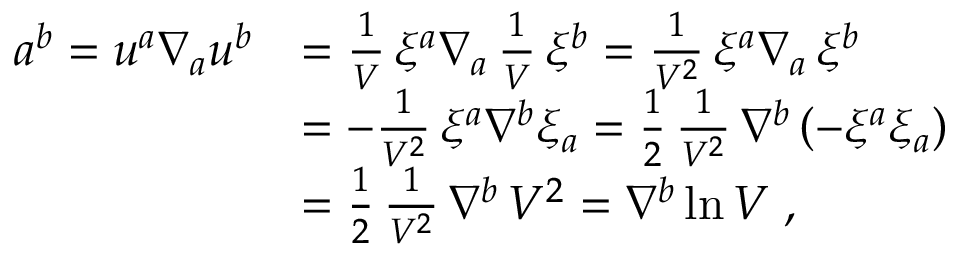Convert formula to latex. <formula><loc_0><loc_0><loc_500><loc_500>\begin{array} { l l } { { a ^ { b } = u ^ { a } \nabla _ { a } u ^ { b } } } & { { = { \frac { 1 } { V } } \, \xi ^ { a } \nabla _ { a } \, { \frac { 1 } { V } } \, \xi ^ { b } = { \frac { 1 } { V ^ { 2 } } } \, \xi ^ { a } \nabla _ { a } \, \xi ^ { b } } } & { { = - { \frac { 1 } { V ^ { 2 } } } \, \xi ^ { a } \nabla ^ { b } \xi _ { a } = { \frac { 1 } { 2 } } \, { \frac { 1 } { V ^ { 2 } } } \, \nabla ^ { b } \left ( - \xi ^ { a } \xi _ { a } \right ) } } & { { = { \frac { 1 } { 2 } } \, { \frac { 1 } { V ^ { 2 } } } \, \nabla ^ { b } \, V ^ { 2 } = \nabla ^ { b } \ln V \, , } } \end{array}</formula> 